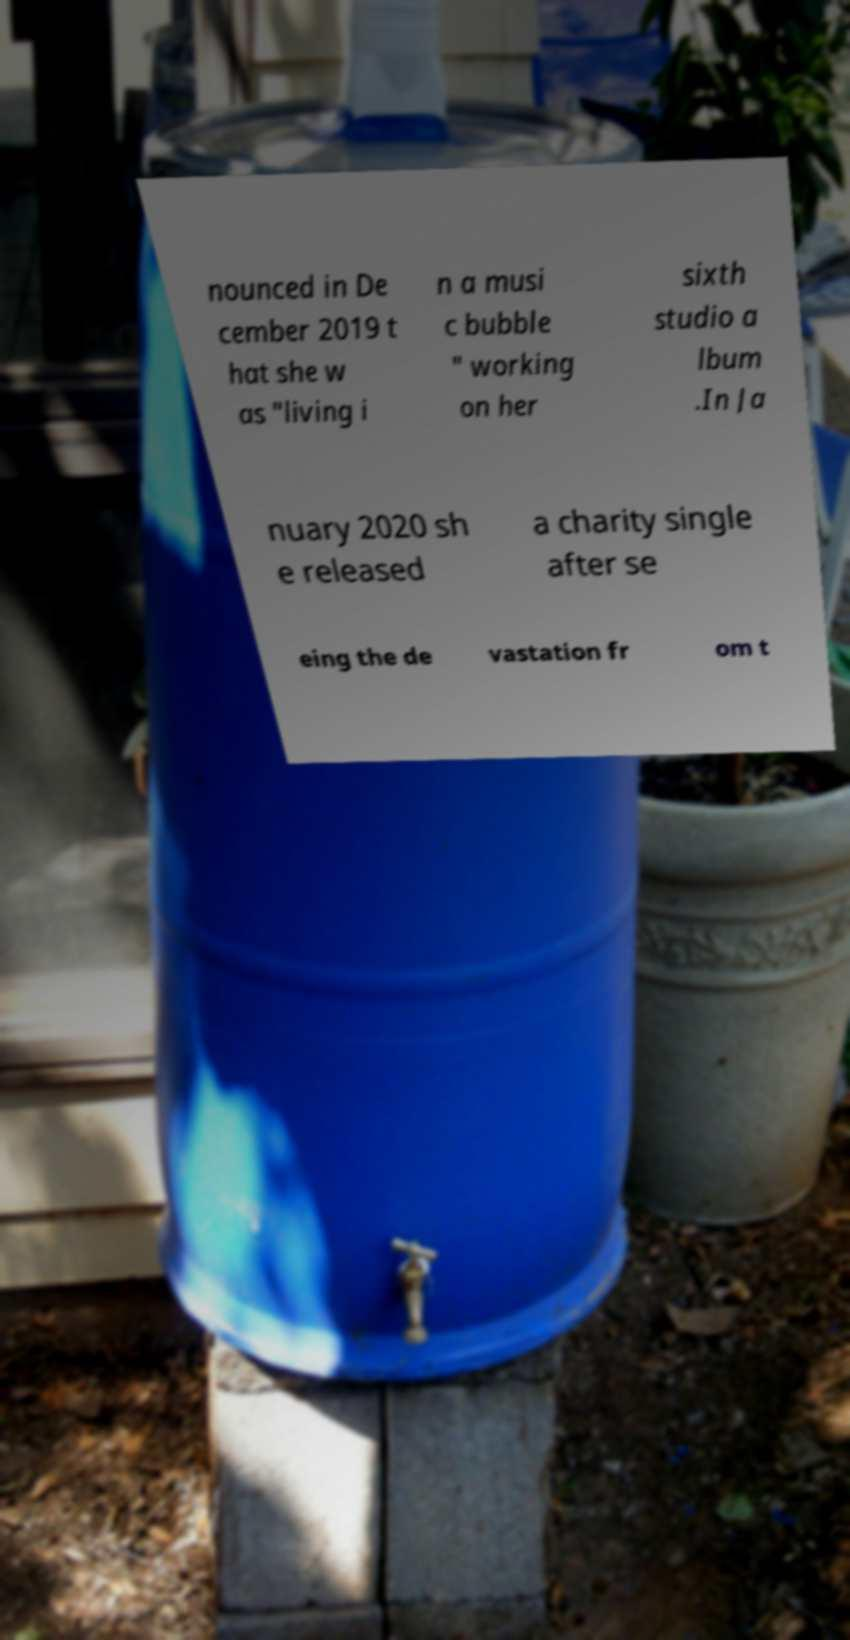Please identify and transcribe the text found in this image. nounced in De cember 2019 t hat she w as "living i n a musi c bubble " working on her sixth studio a lbum .In Ja nuary 2020 sh e released a charity single after se eing the de vastation fr om t 